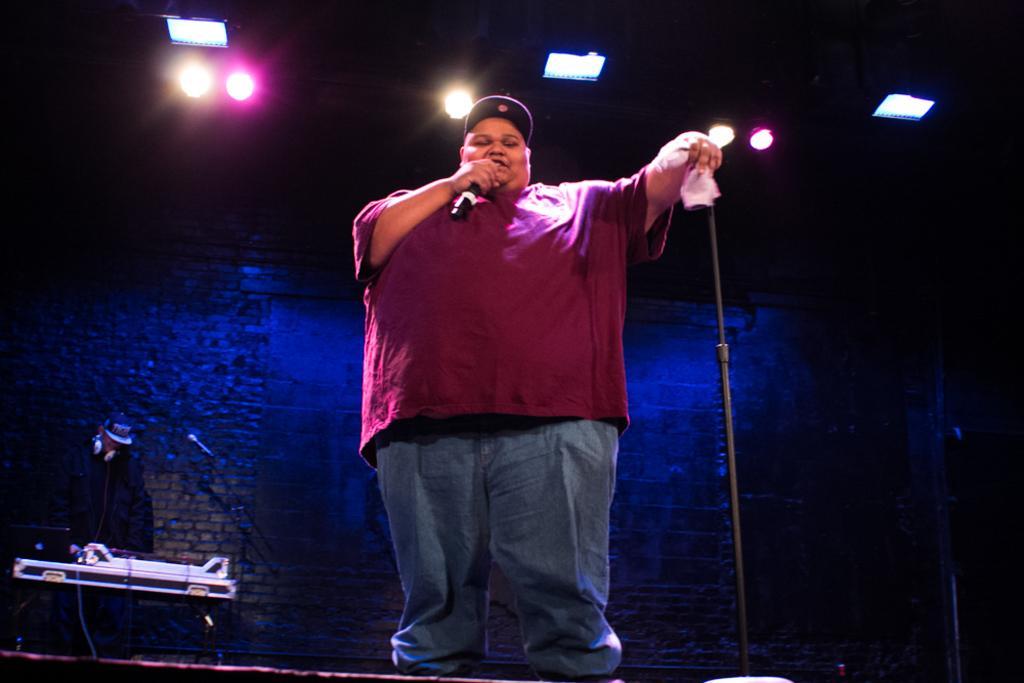How would you summarize this image in a sentence or two? In this picture I can see there is a man standing and holding a microphone in the right hand and a white color object in his left hand and in the backdrop there is another person standing and he is playing a piano and there is a wall, there are lights attached to the ceiling. 